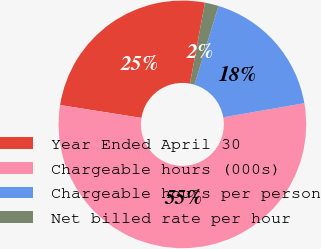Convert chart to OTSL. <chart><loc_0><loc_0><loc_500><loc_500><pie_chart><fcel>Year Ended April 30<fcel>Chargeable hours (000s)<fcel>Chargeable hours per person<fcel>Net billed rate per hour<nl><fcel>25.43%<fcel>55.23%<fcel>17.56%<fcel>1.79%<nl></chart> 